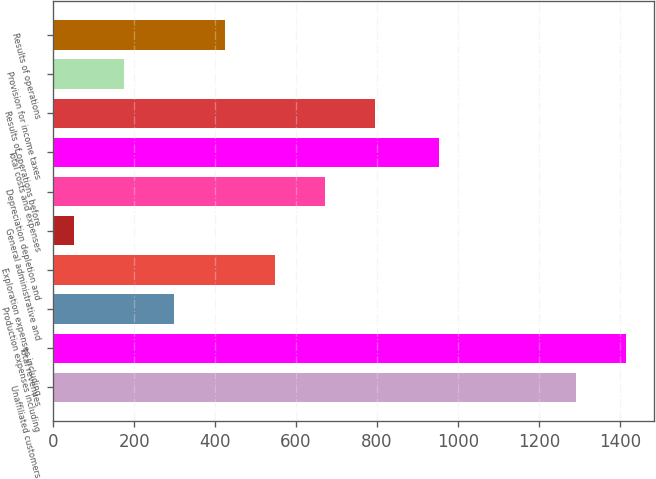Convert chart to OTSL. <chart><loc_0><loc_0><loc_500><loc_500><bar_chart><fcel>Unaffiliated customers<fcel>Total revenues<fcel>Production expenses including<fcel>Exploration expenses including<fcel>General administrative and<fcel>Depreciation depletion and<fcel>Total costs and expenses<fcel>Results of operations before<fcel>Provision for income taxes<fcel>Results of operations<nl><fcel>1290<fcel>1413.8<fcel>299.6<fcel>547.2<fcel>52<fcel>671<fcel>952<fcel>794.8<fcel>175.8<fcel>423.4<nl></chart> 